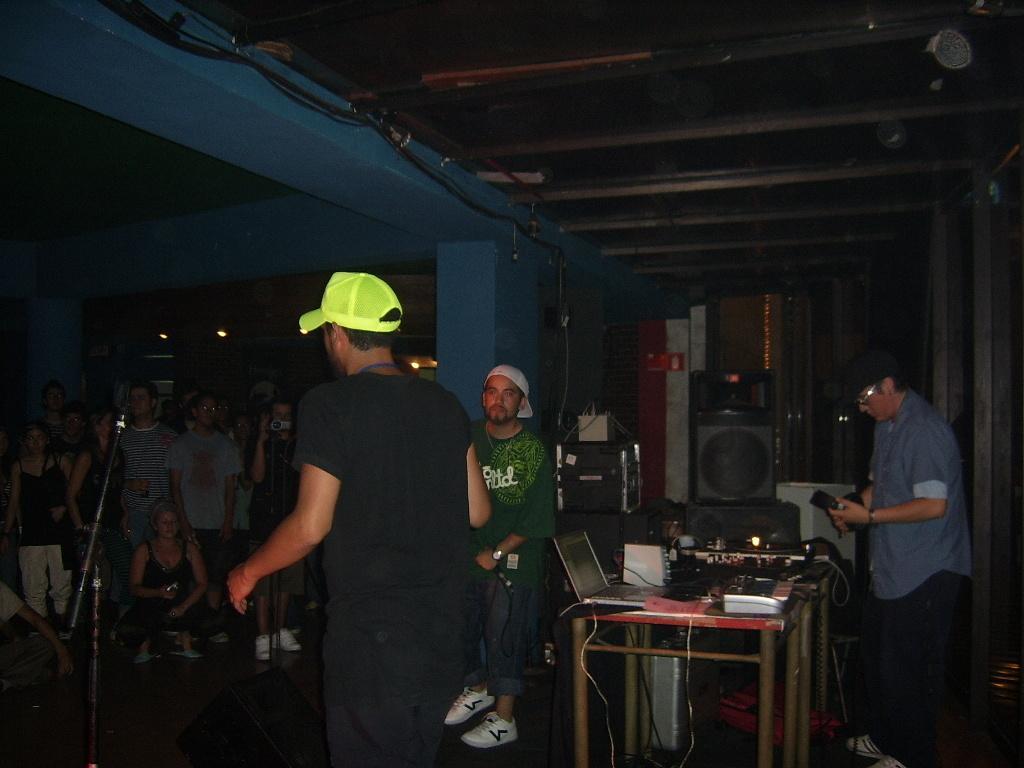Can you describe this image briefly? A man wearing yellow cap is speaking to a group of people in front of him. 